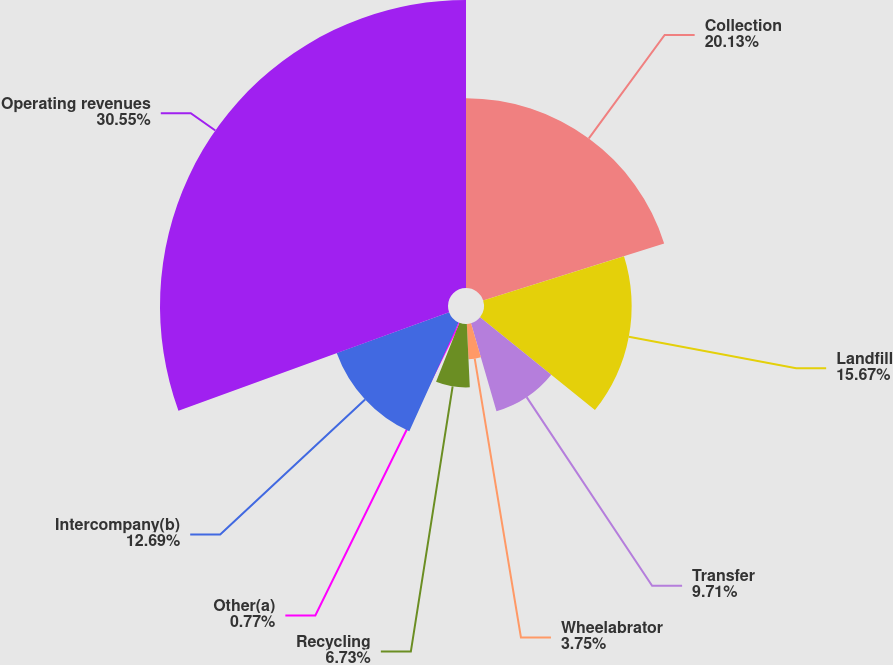<chart> <loc_0><loc_0><loc_500><loc_500><pie_chart><fcel>Collection<fcel>Landfill<fcel>Transfer<fcel>Wheelabrator<fcel>Recycling<fcel>Other(a)<fcel>Intercompany(b)<fcel>Operating revenues<nl><fcel>20.14%<fcel>15.67%<fcel>9.71%<fcel>3.75%<fcel>6.73%<fcel>0.77%<fcel>12.69%<fcel>30.56%<nl></chart> 